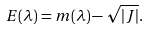Convert formula to latex. <formula><loc_0><loc_0><loc_500><loc_500>E ( \lambda ) = m ( \lambda ) - \sqrt { | J | } .</formula> 